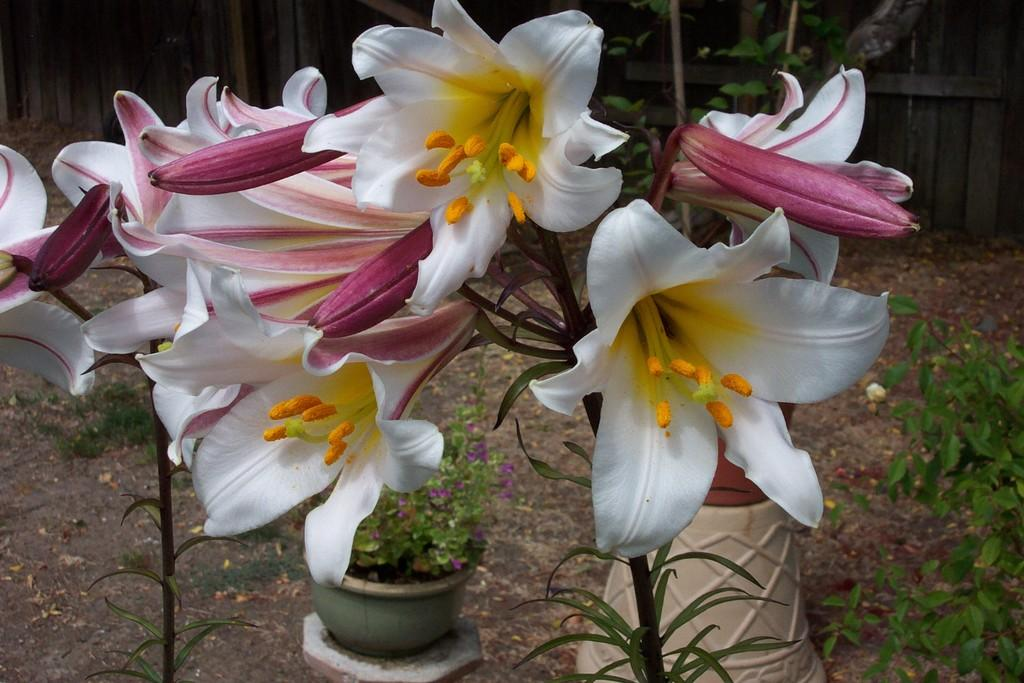What type of plants are visible in the image? There are flowers with stems and leaves in the image. What can be seen in the background of the image? There are pots, plants, grass, and a wall in the background of the image. What type of baseball can be seen in the image? There is no baseball present in the image. What is the texture of the flowers in the image? The provided facts do not mention the texture of the flowers, so it cannot be determined from the image. 